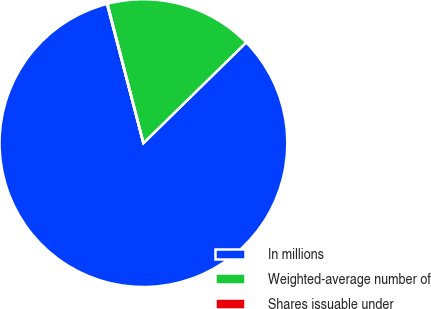<chart> <loc_0><loc_0><loc_500><loc_500><pie_chart><fcel>In millions<fcel>Weighted-average number of<fcel>Shares issuable under<nl><fcel>83.27%<fcel>16.69%<fcel>0.05%<nl></chart> 